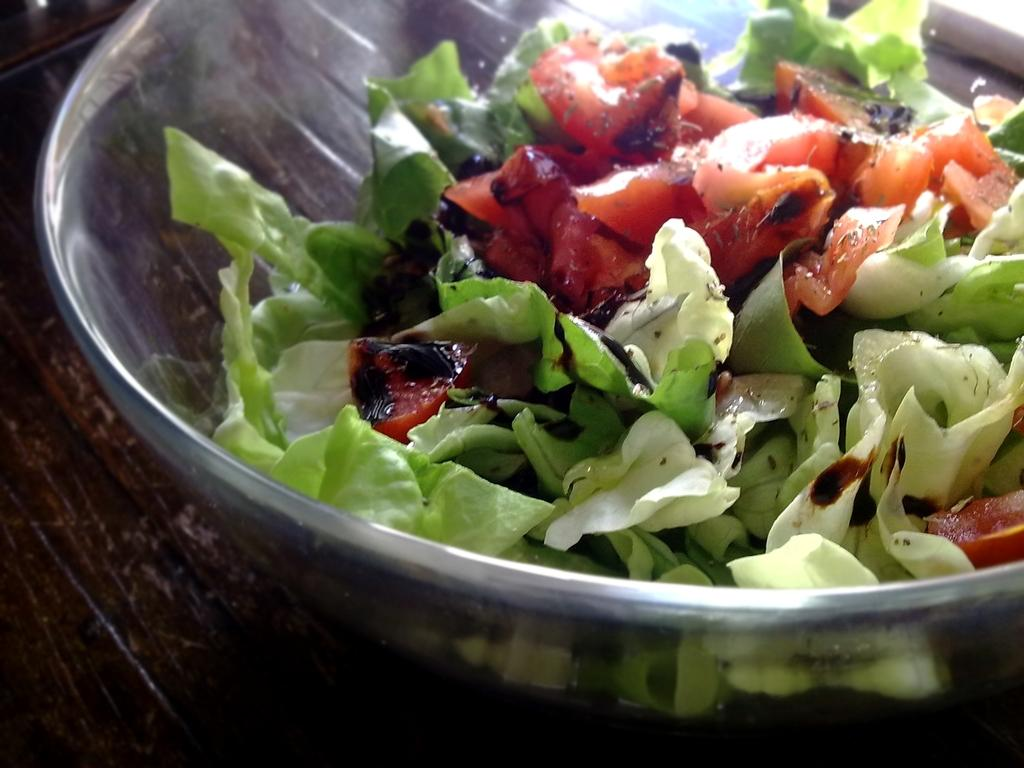What is located in the center of the image? There is a bowl in the center of the image. What is inside the bowl? The bowl contains salad. What type of furniture is at the bottom of the image? There is a table at the bottom of the image. What type of wax can be seen melting on the table in the image? There is no wax present in the image; it features a bowl of salad on a table. 